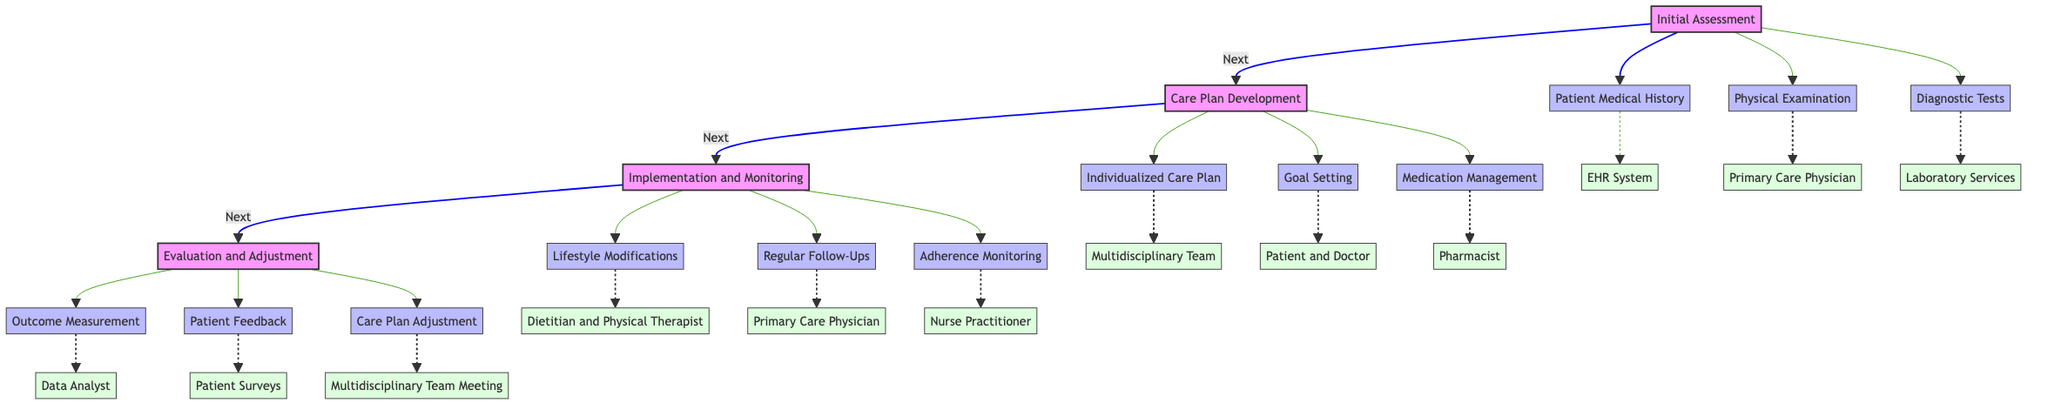What is the first stage in the chronic disease management pathway? The diagram indicates "Initial Assessment" as the first stage in the flow of the pathway.
Answer: Initial Assessment How many tasks are there in the Care Plan Development stage? In the Care Plan Development stage, there are three tasks listed: Individualized Care Plan, Goal Setting, and Medication Management.
Answer: 3 Which entity is responsible for outcome measurement in the evaluation stage? The outcome measurement task is linked to the Data Analyst entity in the evaluation stage of the pathway.
Answer: Data Analyst What follows the Implementation and Monitoring stage? The diagram shows that "Evaluation and Adjustment" is the next stage after "Implementation and Monitoring."
Answer: Evaluation and Adjustment Which entity is involved in adherence monitoring? The adherence monitoring task falls under the responsibility of the Nurse Practitioner as indicated in the diagram.
Answer: Nurse Practitioner What is included in the Initial Assessment stage along with physical examination? Besides physical examination, "Patient Medical History" is another task in the Initial Assessment stage.
Answer: Patient Medical History How many entities are associated with the Care Plan Development tasks? There are three entities associated with the Care Plan Development tasks: Multidisciplinary Team, Patient and Doctor, and Pharmacist.
Answer: 3 Which task involves dietary changes and which entities are responsible? The task "Lifestyle Modifications" involves dietary changes and is addressed by the Dietitian and Physical Therapist.
Answer: Lifestyle Modifications What allows for feedback during the evaluation stage? The "Patient Feedback" task allows for feedback during the evaluation stage, according to the diagram.
Answer: Patient Feedback 